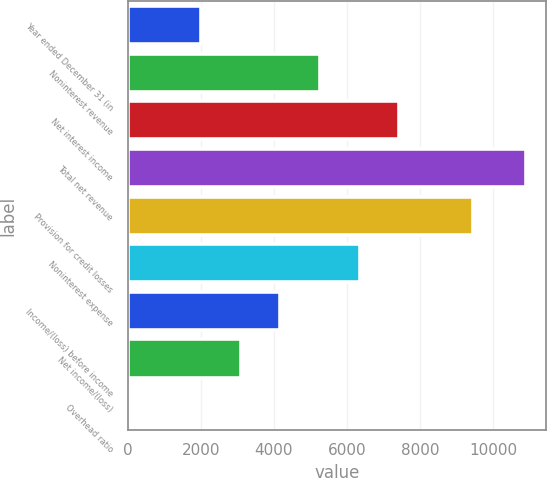<chart> <loc_0><loc_0><loc_500><loc_500><bar_chart><fcel>Year ended December 31 (in<fcel>Noninterest revenue<fcel>Net interest income<fcel>Total net revenue<fcel>Provision for credit losses<fcel>Noninterest expense<fcel>Income/(loss) before income<fcel>Net income/(loss)<fcel>Overhead ratio<nl><fcel>2008<fcel>5267.8<fcel>7441<fcel>10910<fcel>9456<fcel>6354.4<fcel>4181.2<fcel>3094.6<fcel>44<nl></chart> 